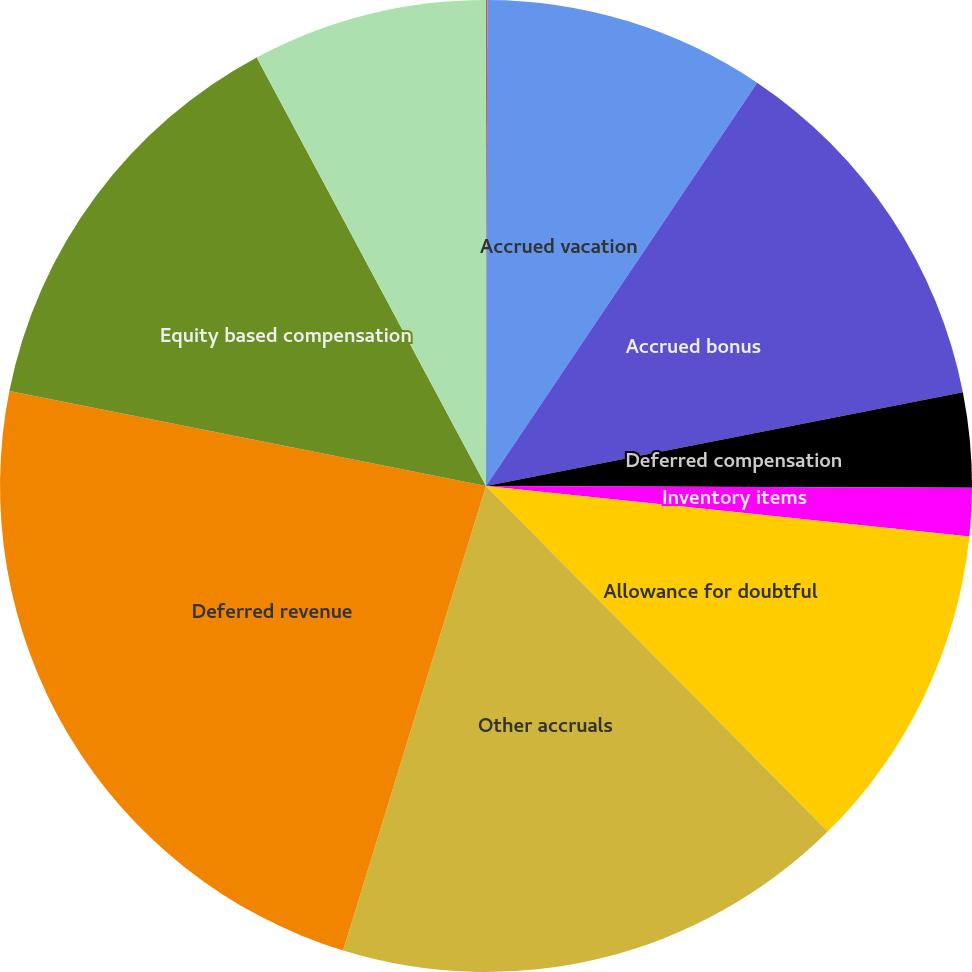Convert chart. <chart><loc_0><loc_0><loc_500><loc_500><pie_chart><fcel>Deferred rent<fcel>Accrued vacation<fcel>Accrued bonus<fcel>Deferred compensation<fcel>Inventory items<fcel>Allowance for doubtful<fcel>Other accruals<fcel>Deferred revenue<fcel>Equity based compensation<fcel>Unrealized gain on securities<nl><fcel>0.04%<fcel>9.38%<fcel>12.49%<fcel>3.15%<fcel>1.6%<fcel>10.93%<fcel>17.16%<fcel>23.38%<fcel>14.05%<fcel>7.82%<nl></chart> 